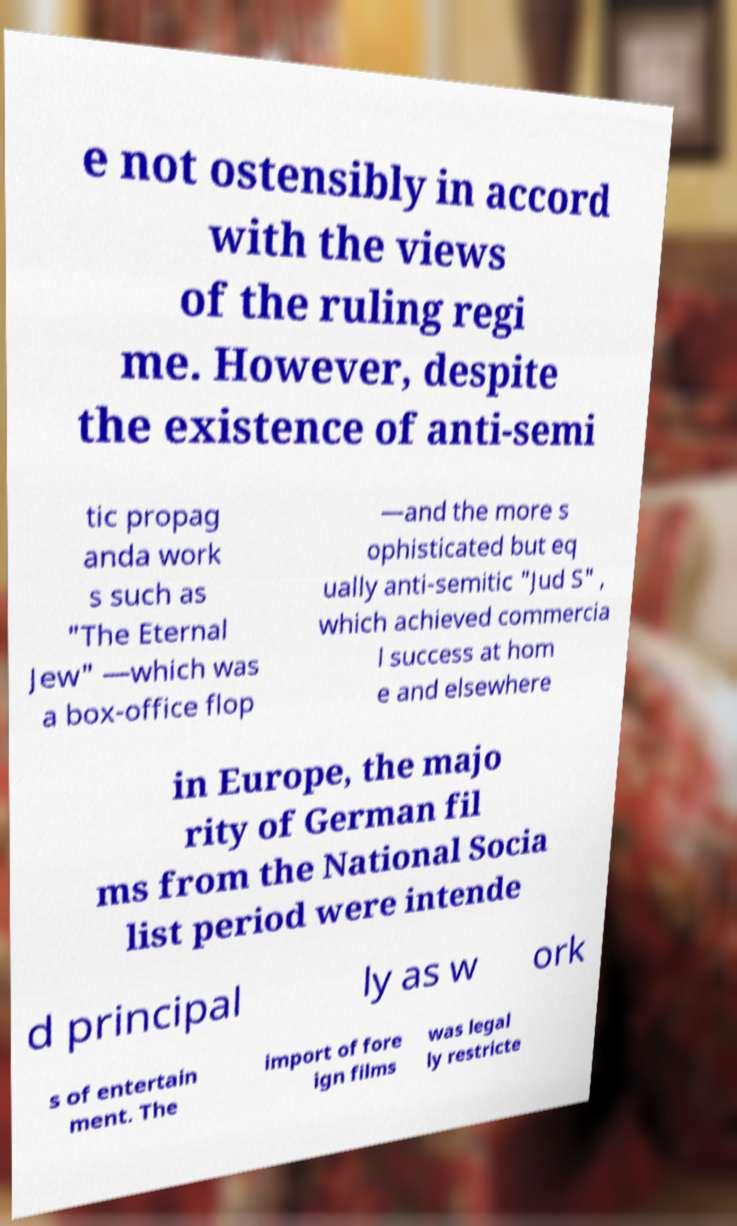Please identify and transcribe the text found in this image. e not ostensibly in accord with the views of the ruling regi me. However, despite the existence of anti-semi tic propag anda work s such as "The Eternal Jew" —which was a box-office flop —and the more s ophisticated but eq ually anti-semitic "Jud S" , which achieved commercia l success at hom e and elsewhere in Europe, the majo rity of German fil ms from the National Socia list period were intende d principal ly as w ork s of entertain ment. The import of fore ign films was legal ly restricte 